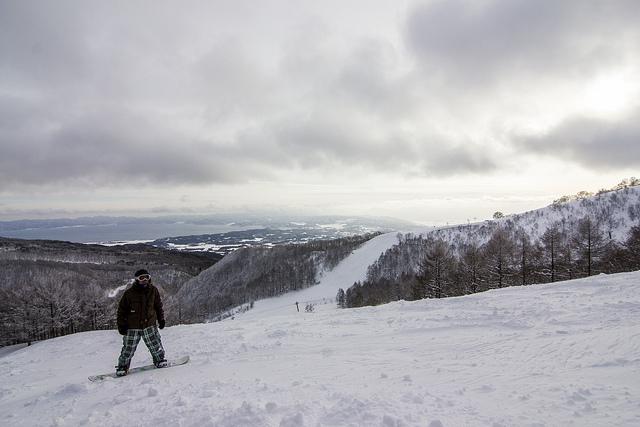Is the person going fast?
Short answer required. No. Is it snowing?
Quick response, please. No. What is the man wearing?
Be succinct. Jacket. Has it recently snowed?
Concise answer only. Yes. What sport is shown here?
Answer briefly. Snowboarding. 